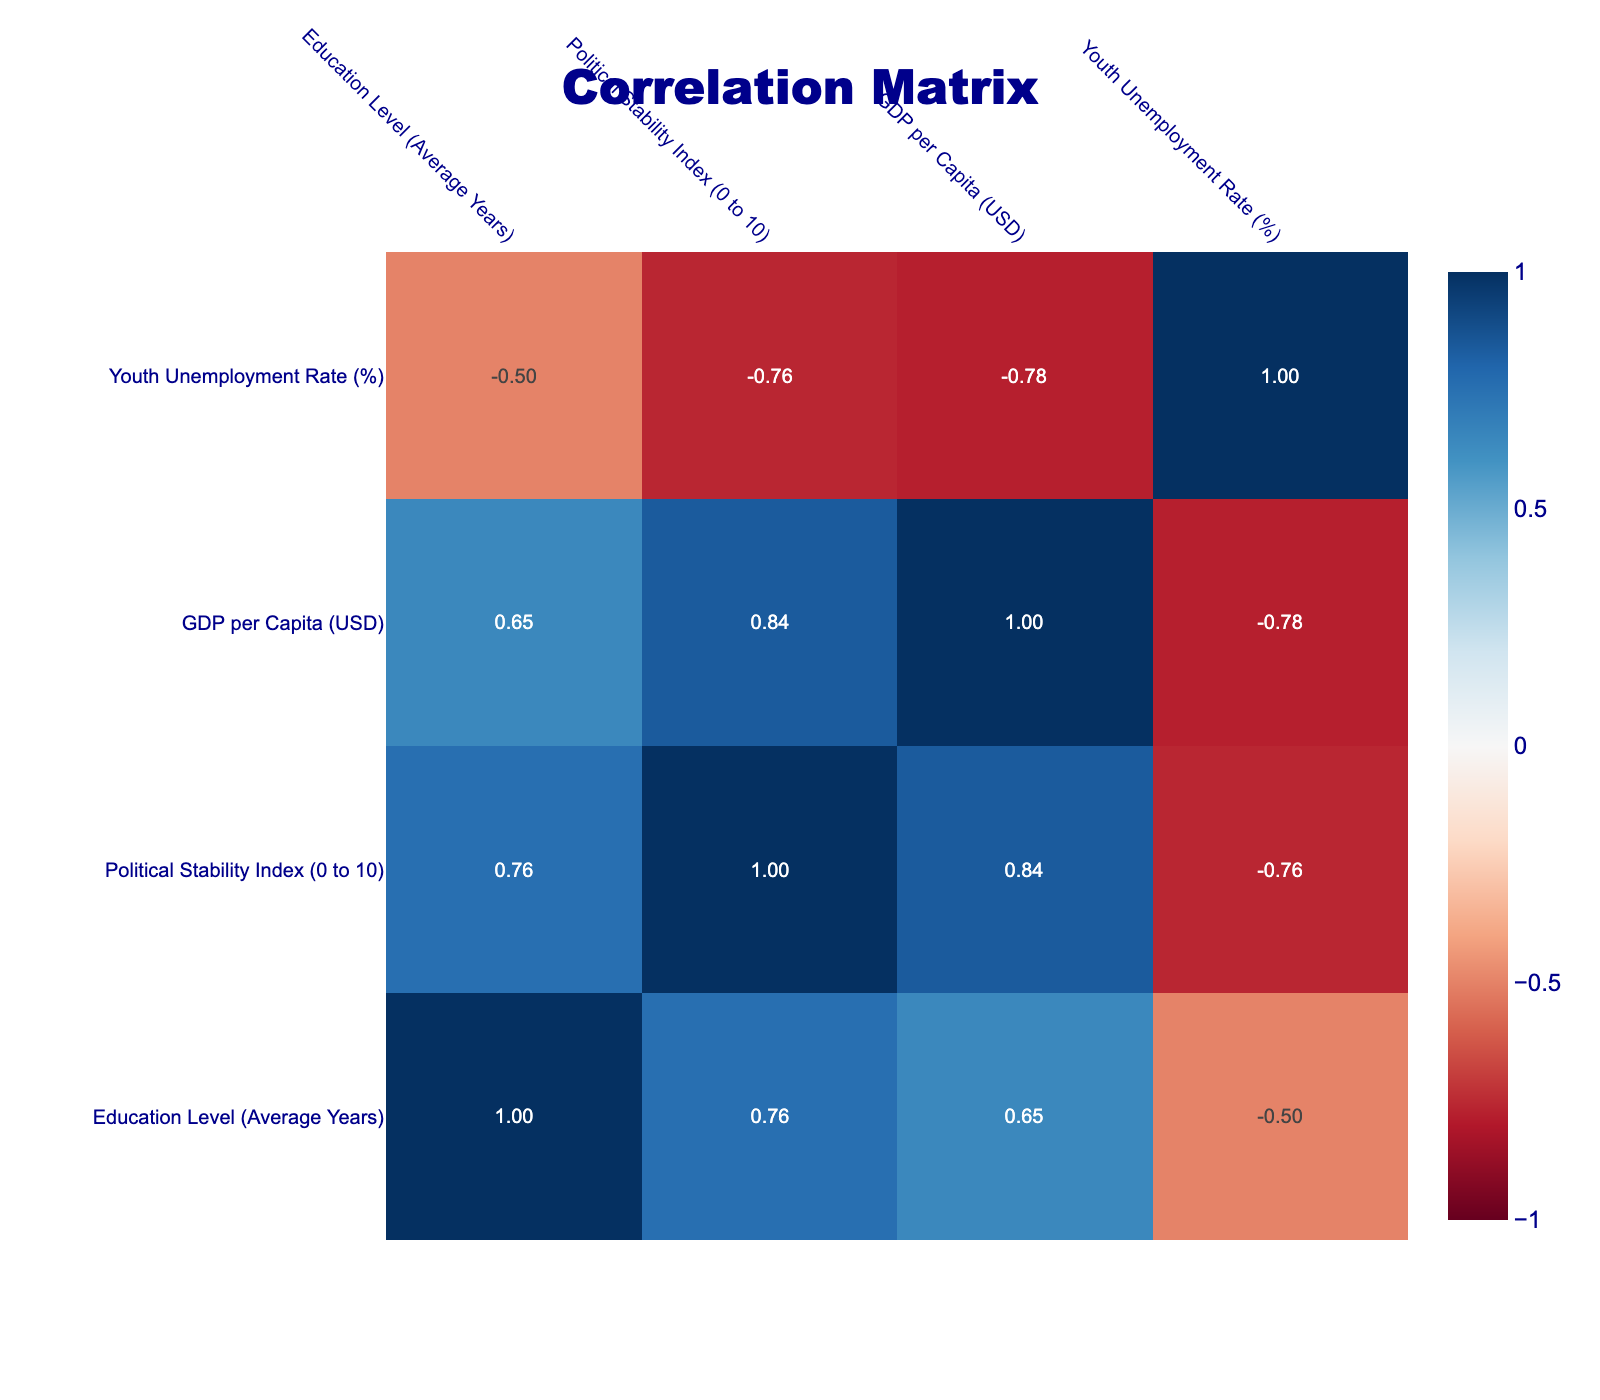What is the political stability index of Egypt? The political stability index for Egypt is provided directly in the table as 4.5.
Answer: 4.5 Which country has the highest average years of education? When reviewing the average years of education from the table, Qatar has the highest with 16 years.
Answer: 16 Is it true that the country with the lowest political stability index, Iraq, also has the lowest average years of education? Iraq has a political stability index of 2.5, which is the lowest, while it has an average education level of 10 years. However, Lebanon, with a political stability index of 3.9, has an average of 11 years of education. Thus, the statement is false.
Answer: No What is the correlation between education level and political stability index? To find this, I look at the correlation coefficients in the table. A positive correlation indicates that as education levels rise, political stability tends to increase. Analyzing the values, the correlation is significant, so a higher education level is associated with a more stable political climate.
Answer: Positive correlation What is the difference in GDP per capita between the countries with the highest and lowest political stability indices? Qatar has the highest political stability index at 8.9 and a GDP per capita of 60000 USD. Iraq has the lowest political stability index at 2.5 and a GDP per capita of 4300 USD. The difference is calculated as 60000 - 4300 = 55600 USD.
Answer: 55600 Which country has the highest youth unemployment rate among the listed countries? By scanning the table for youth unemployment rates, Lebanon has the highest rate at 36.5%.
Answer: 36.5 Calculate the average political stability index for the countries with average education levels greater than 12 years. The countries that meet this criterion are Turkey (5.8), United Arab Emirates (8.5), Qatar (8.9), and Saudi Arabia (7.1). Adding these gives a total of 30.3. There are 4 countries, so the average is 30.3 / 4 = 7.575.
Answer: 7.58 Is there a country with a low education level that has a high political stability index? Examining the table, Iraq has the lowest education level at 10 years and a political stability index of 2.5, while Lebanon, with 11 years of education, has a higher political stability index at 3.9. There is no low education country with a high stability index in this case.
Answer: No What is the average youth unemployment rate for the countries listed? The youth unemployment rates are 30.1, 24.3, 17.0, 9.2, 12.8, 36.5, 25.7, 21.9, 7.5, and 5.1, a total of 10 values. To find the average, sum these rates, which equals 289.1, and divide by 10 giving an average of 28.91%.
Answer: 28.91 